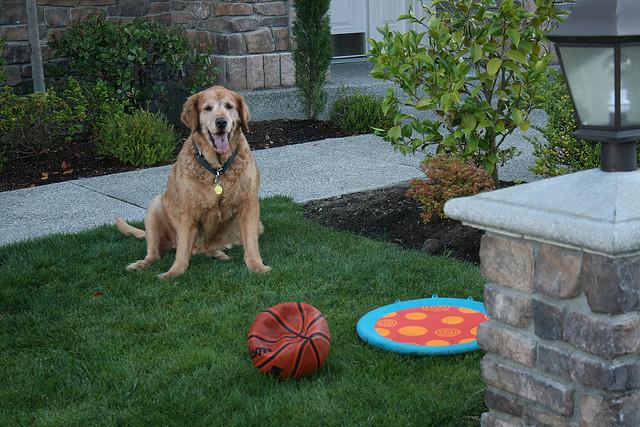What color is the ball?
Keep it brief. Orange. Is the dog looking at the bricks or the boat?
Short answer required. Bricks. Are the dog's eyes open or closed?
Short answer required. Open. What is the dog standing near?
Short answer required. Basketball. What is in the picture?
Write a very short answer. Dog. 